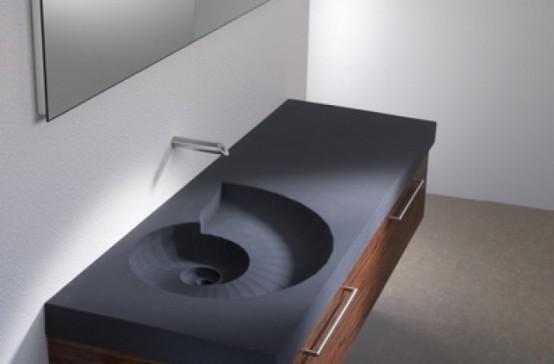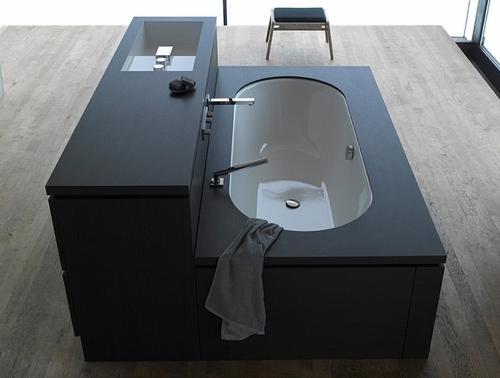The first image is the image on the left, the second image is the image on the right. Assess this claim about the two images: "One image shows a rectangular vanity with a shell-shaped sink carved into it, beneath a fauced mounted on the wall.". Correct or not? Answer yes or no. Yes. The first image is the image on the left, the second image is the image on the right. Considering the images on both sides, is "The sink in the right image has a black counter top." valid? Answer yes or no. Yes. 